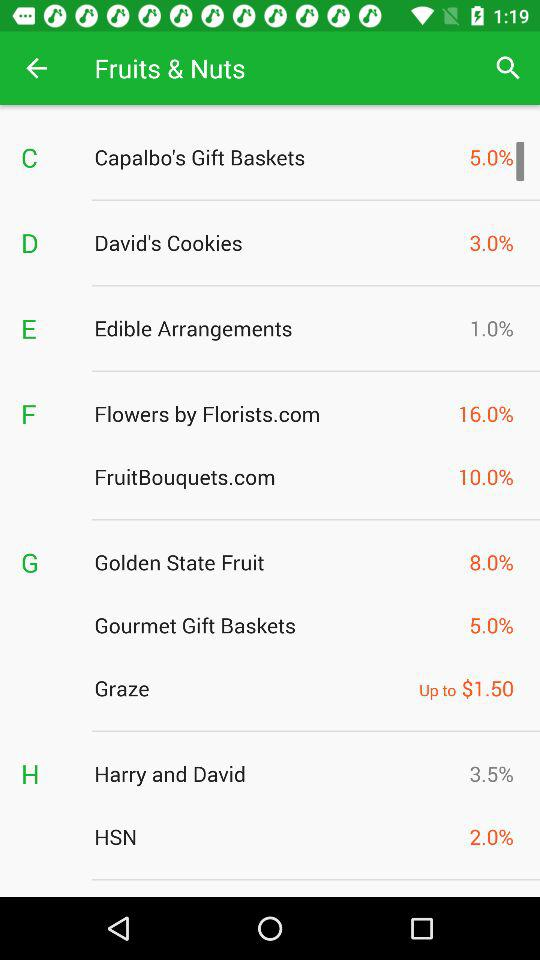What is the percentage of David's cookies? The percentage of David's cookies is 3.0. 